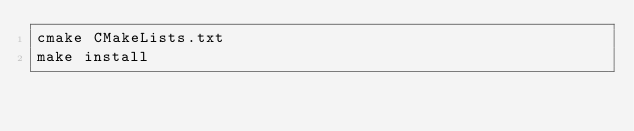Convert code to text. <code><loc_0><loc_0><loc_500><loc_500><_Bash_>cmake CMakeLists.txt
make install
</code> 